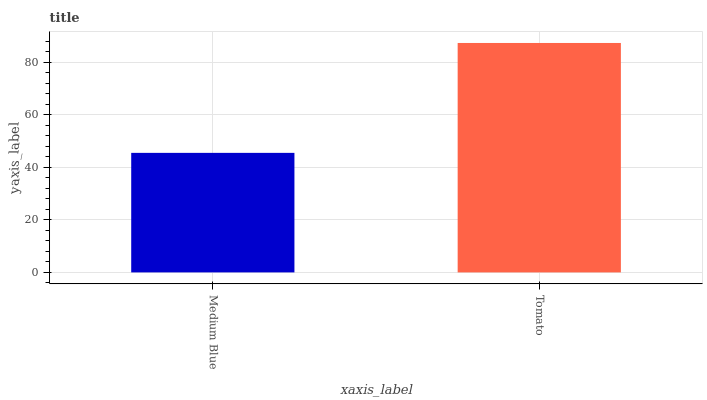Is Medium Blue the minimum?
Answer yes or no. Yes. Is Tomato the maximum?
Answer yes or no. Yes. Is Tomato the minimum?
Answer yes or no. No. Is Tomato greater than Medium Blue?
Answer yes or no. Yes. Is Medium Blue less than Tomato?
Answer yes or no. Yes. Is Medium Blue greater than Tomato?
Answer yes or no. No. Is Tomato less than Medium Blue?
Answer yes or no. No. Is Tomato the high median?
Answer yes or no. Yes. Is Medium Blue the low median?
Answer yes or no. Yes. Is Medium Blue the high median?
Answer yes or no. No. Is Tomato the low median?
Answer yes or no. No. 